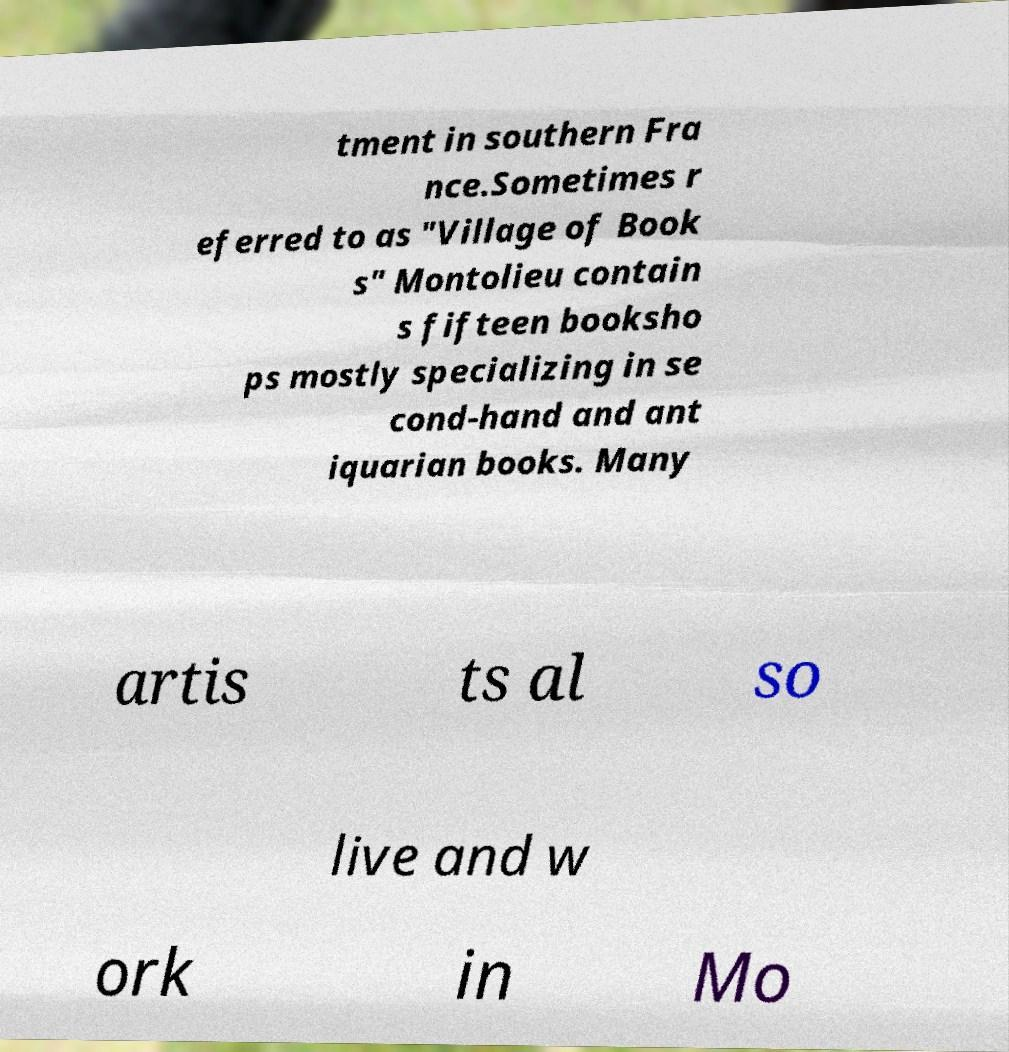Could you extract and type out the text from this image? tment in southern Fra nce.Sometimes r eferred to as "Village of Book s" Montolieu contain s fifteen booksho ps mostly specializing in se cond-hand and ant iquarian books. Many artis ts al so live and w ork in Mo 